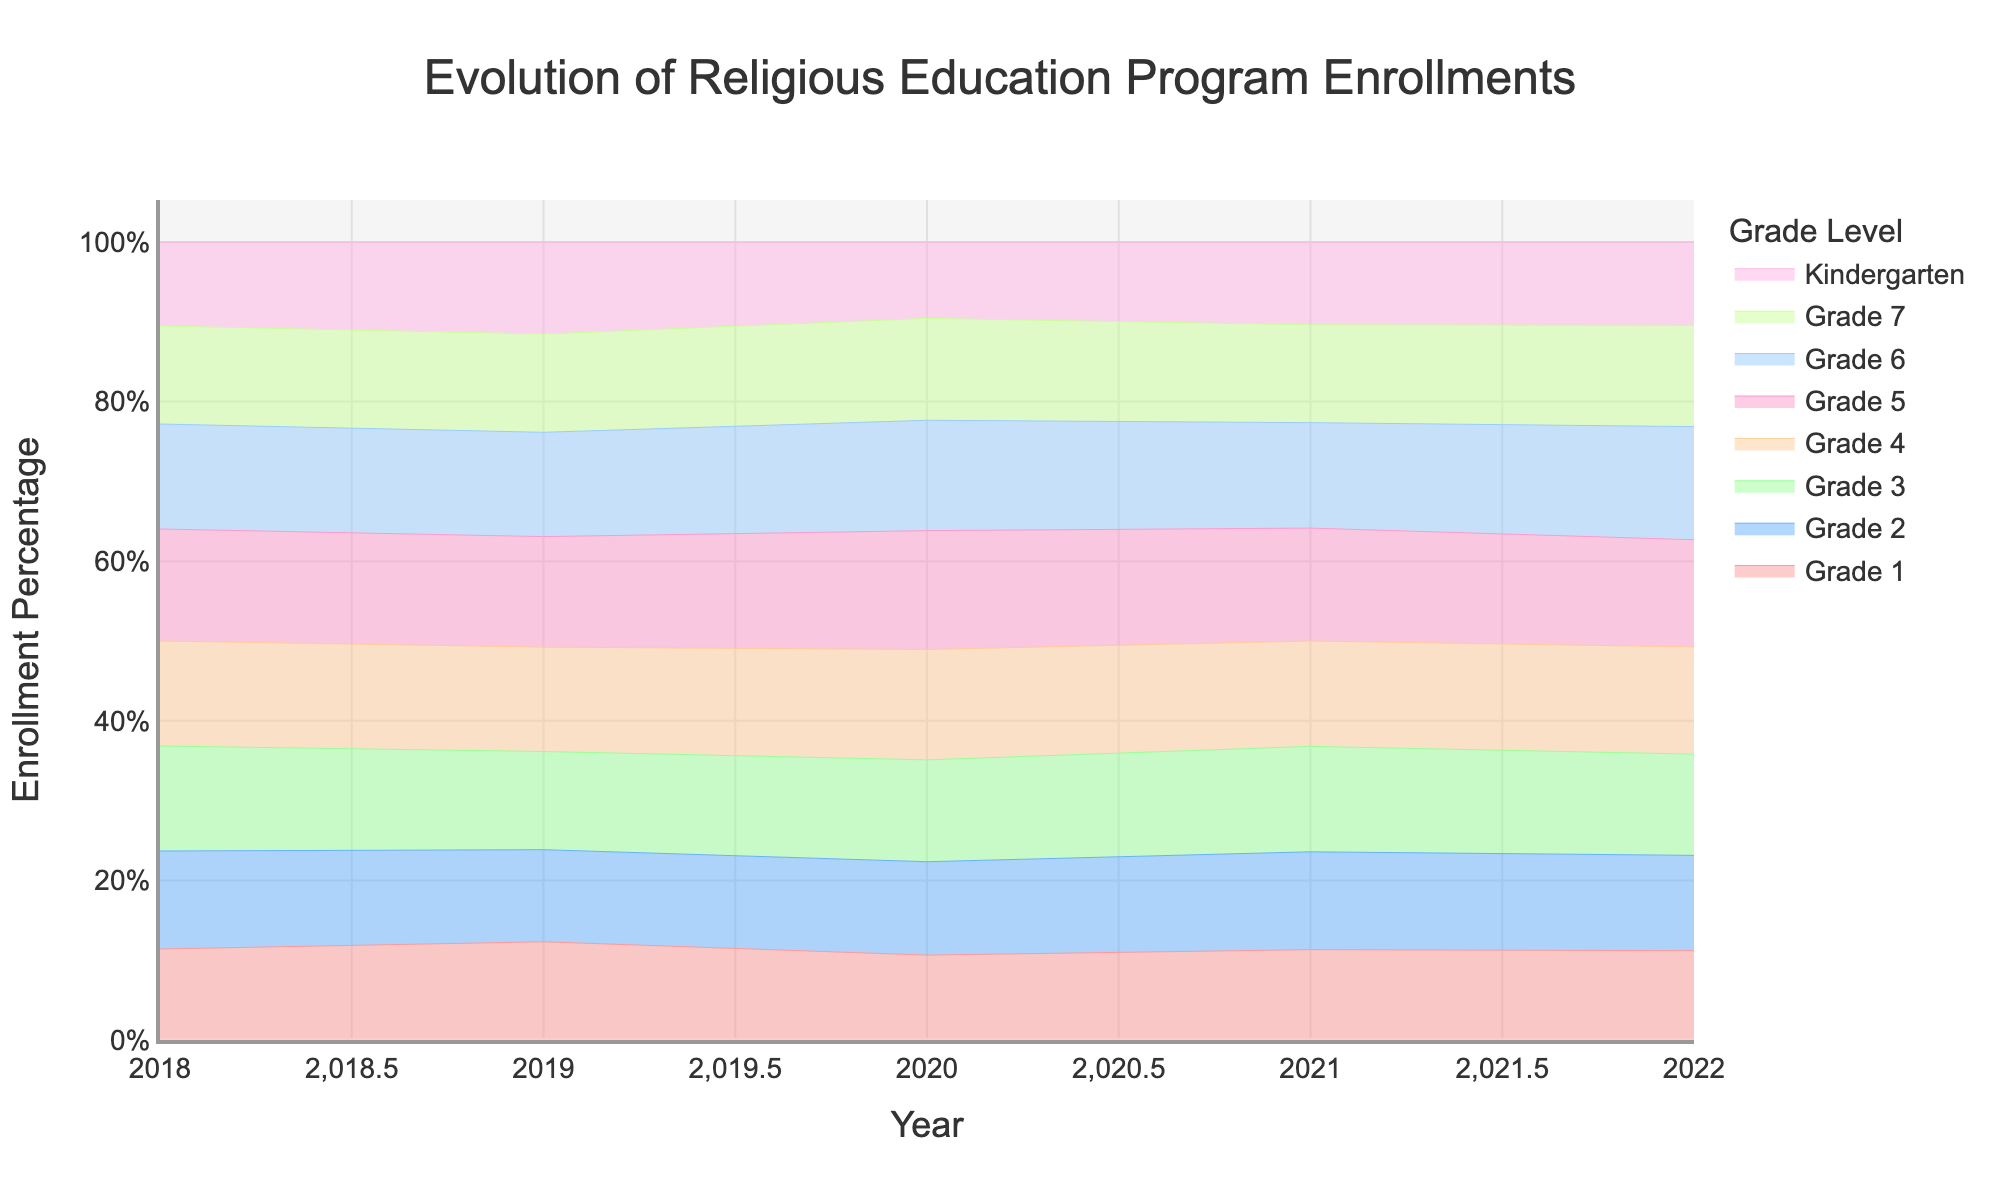what does the title of the figure indicate? The title "Evolution of Religious Education Program Enrollments" explains that the figure shows how enrollments in the religious education program have changed over time.
Answer: Evolution of Religious Education Program Enrollments How does the enrollment percentage of Kindergarten in 2020 compare to other grades? By visual inspection, Kindergarten has a noticeable dip in 2020 compared to other grades, showing a decline in enrollment percentage.
Answer: Lower than most other grades Which year shows the highest overall enrollment percentage for Grade 3? We can see that the stream for Grade 3 reaches its highest point in 2022. This indicates the year with the highest enrollment percentage for Grade 3.
Answer: 2022 What is the enrollment trend over the years for Grade 6? The stream for Grade 6 shows an overall upward trend, with some fluctuations, increasing from 2018 to its highest point in 2022.
Answer: Upward trend What was the enrollment percentage trend for Grade 5 between 2018 and 2020? Analyzing the stream graph, Grade 5's enrollment percentage shows an initial increase from 2018 to 2019, followed by a slight decline in 2020.
Answer: Increase, then decrease Which grade levels had a noticeable drop in enrollment percentage in 2020? By looking at the dips in the streams, Kindergarten, Grade 1, and Grade 6 had noticeable drops in 2020.
Answer: Kindergarten, Grade 1, Grade 6 Do any grade levels have a consistent increase in enrollment percentage across all years? Examination of each stream shows that Grades 2 and Grade 6 both have a consistent increase in enrollment percentage throughout all years.
Answer: Grade 2, Grade 6 Which grade has the most fluctuating enrollment trend from 2018 to 2022? Observing the streams, Grade 7 shows the most visible fluctuations in enrollment percentages from 2018 to 2022.
Answer: Grade 7 